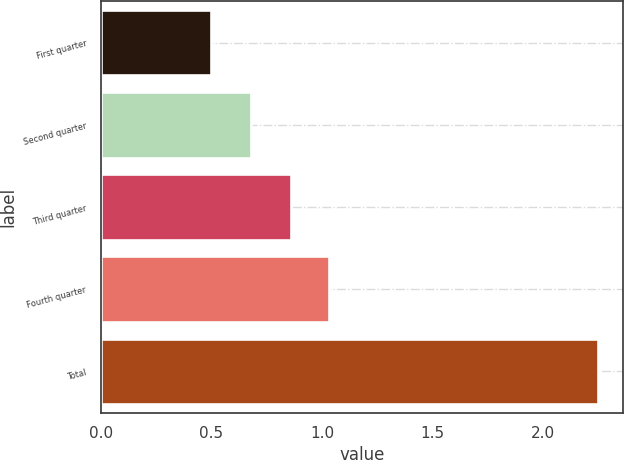<chart> <loc_0><loc_0><loc_500><loc_500><bar_chart><fcel>First quarter<fcel>Second quarter<fcel>Third quarter<fcel>Fourth quarter<fcel>Total<nl><fcel>0.5<fcel>0.68<fcel>0.86<fcel>1.03<fcel>2.25<nl></chart> 